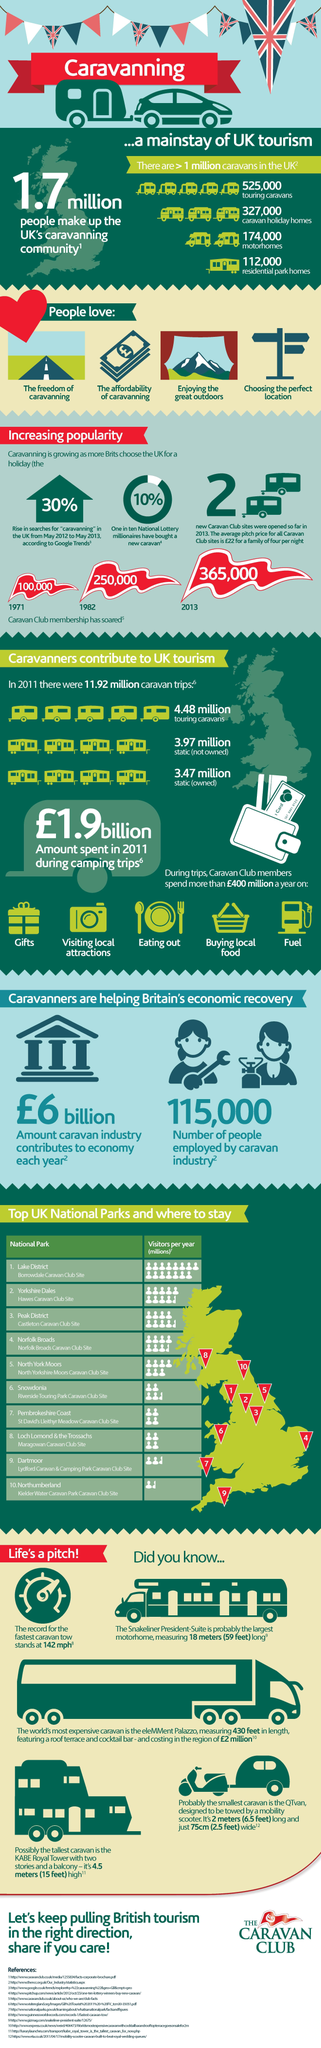Give some essential details in this illustration. It has been reported that approximately 10% of lottery winners in the country have taken a new caravan. The contribution of Trip caravan to UK tourism is estimated to be 4.48 million. The caravan industry provided jobs to approximately 115,000 people. The affordability of caravanning is the second point listed under the heading "People love". In the year 1982, it is reported that approximately 250,000 individuals joined the Caravan Club in the United Kingdom. 